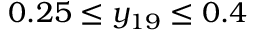Convert formula to latex. <formula><loc_0><loc_0><loc_500><loc_500>0 . 2 5 \leq y _ { 1 9 } \leq 0 . 4</formula> 